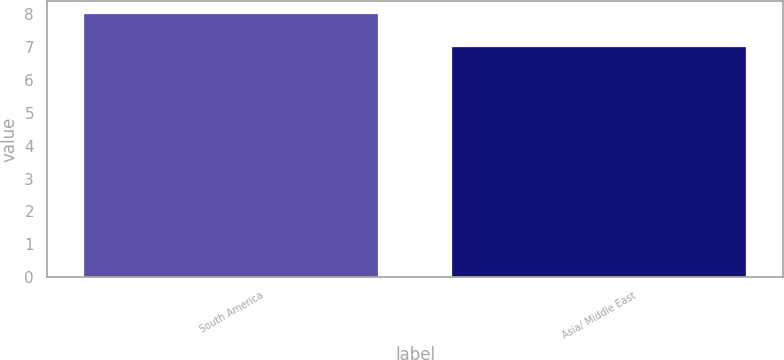Convert chart. <chart><loc_0><loc_0><loc_500><loc_500><bar_chart><fcel>South America<fcel>Asia/ Middle East<nl><fcel>8<fcel>7<nl></chart> 